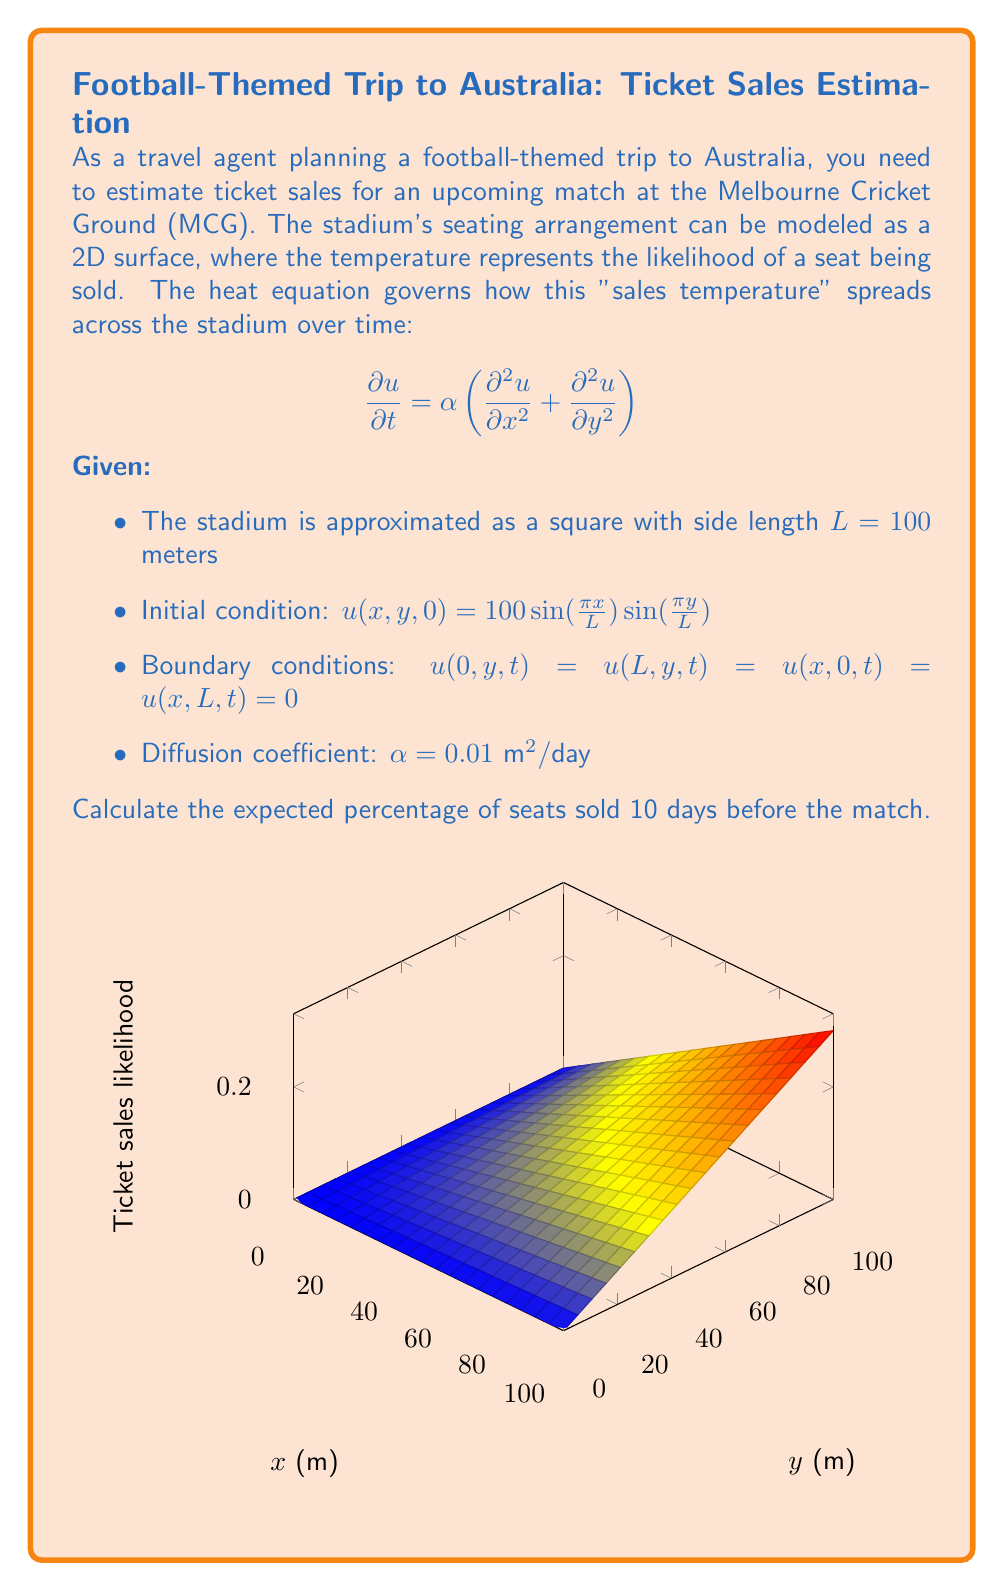Show me your answer to this math problem. To solve this problem, we'll use the method of separation of variables for the 2D heat equation.

Step 1: Assume a solution of the form $u(x,y,t) = X(x)Y(y)T(t)$.

Step 2: Substituting into the heat equation and separating variables:

$$\frac{T'(t)}{αT(t)} = \frac{X''(x)}{X(x)} + \frac{Y''(y)}{Y(y)} = -k^2$$

Step 3: Solve the resulting ODEs:
- $T(t) = Ce^{-αk^2t}$
- $X(x) = A\sin(mx) + B\cos(mx)$, where $m^2 = k^2$
- $Y(y) = D\sin(ny) + E\cos(ny)$, where $n^2 = k^2 - m^2$

Step 4: Apply boundary conditions:
$X(0) = X(L) = 0$ implies $m = \frac{n\pi}{L}$, where n is an integer.
$Y(0) = Y(L) = 0$ implies $n = \frac{m\pi}{L}$, where m is an integer.

Step 5: The general solution is:

$$u(x,y,t) = \sum_{n=1}^{\infty}\sum_{m=1}^{\infty} A_{nm}\sin(\frac{n\pi x}{L})\sin(\frac{m\pi y}{L})e^{-α(\frac{n^2\pi^2}{L^2}+\frac{m^2\pi^2}{L^2})t}$$

Step 6: Match the initial condition:

$$100\sin(\frac{\pi x}{L})\sin(\frac{\pi y}{L}) = \sum_{n=1}^{\infty}\sum_{m=1}^{\infty} A_{nm}\sin(\frac{n\pi x}{L})\sin(\frac{m\pi y}{L})$$

This implies $A_{11} = 100$ and all other $A_{nm} = 0$.

Step 7: The solution becomes:

$$u(x,y,t) = 100\sin(\frac{\pi x}{L})\sin(\frac{\pi y}{L})e^{-2α\frac{\pi^2}{L^2}t}$$

Step 8: Calculate the solution at t = 10 days:

$$u(x,y,10) = 100\sin(\frac{\pi x}{L})\sin(\frac{\pi y}{L})e^{-2(0.01)\frac{\pi^2}{100^2}(10)} \approx 80.85\sin(\frac{\pi x}{L})\sin(\frac{\pi y}{L})$$

Step 9: To find the percentage of seats sold, we need to calculate the average value of u over the stadium:

$$\text{Average} = \frac{1}{L^2}\int_0^L\int_0^L 80.85\sin(\frac{\pi x}{L})\sin(\frac{\pi y}{L})dxdy = \frac{4}{\pi^2} \cdot 80.85 \approx 32.74$$

Therefore, the expected percentage of seats sold 10 days before the match is approximately 32.74%.
Answer: 32.74% 